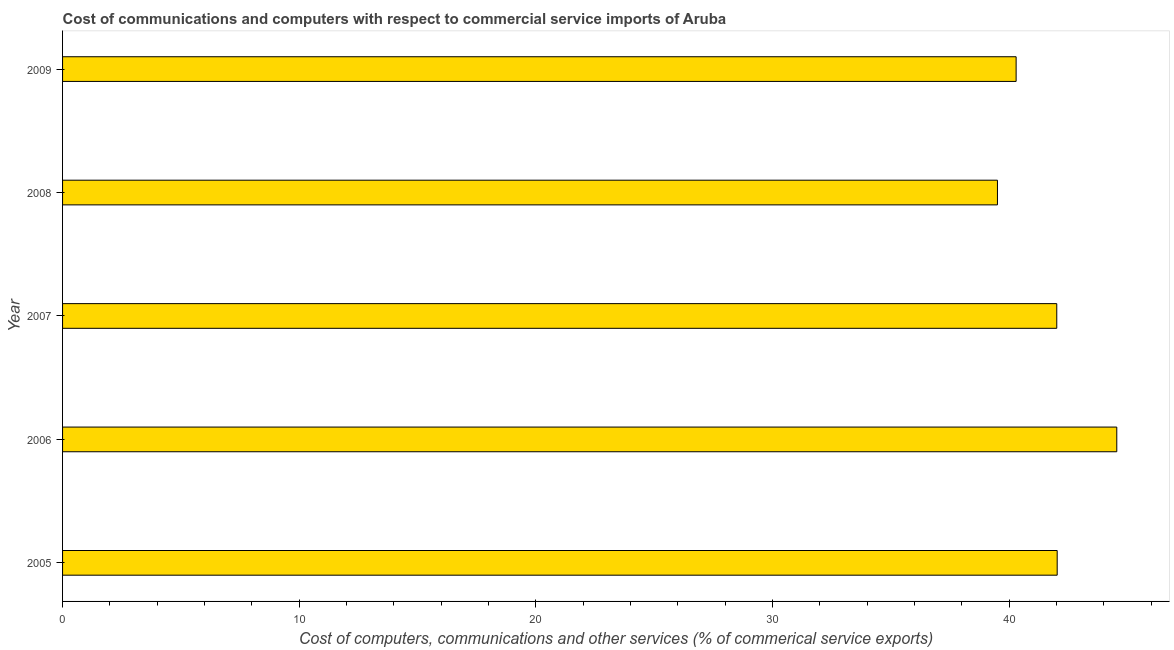What is the title of the graph?
Keep it short and to the point. Cost of communications and computers with respect to commercial service imports of Aruba. What is the label or title of the X-axis?
Provide a succinct answer. Cost of computers, communications and other services (% of commerical service exports). What is the cost of communications in 2008?
Make the answer very short. 39.51. Across all years, what is the maximum cost of communications?
Offer a very short reply. 44.55. Across all years, what is the minimum  computer and other services?
Offer a very short reply. 39.51. In which year was the cost of communications maximum?
Your response must be concise. 2006. What is the sum of the cost of communications?
Your response must be concise. 208.4. What is the difference between the  computer and other services in 2005 and 2006?
Your response must be concise. -2.52. What is the average  computer and other services per year?
Provide a succinct answer. 41.68. What is the median  computer and other services?
Provide a succinct answer. 42.01. Do a majority of the years between 2008 and 2005 (inclusive) have  computer and other services greater than 40 %?
Provide a short and direct response. Yes. What is the ratio of the  computer and other services in 2005 to that in 2009?
Make the answer very short. 1.04. What is the difference between the highest and the second highest  computer and other services?
Ensure brevity in your answer.  2.52. Is the sum of the  computer and other services in 2005 and 2008 greater than the maximum  computer and other services across all years?
Provide a short and direct response. Yes. What is the difference between the highest and the lowest cost of communications?
Your response must be concise. 5.04. How many bars are there?
Your answer should be very brief. 5. How many years are there in the graph?
Give a very brief answer. 5. What is the difference between two consecutive major ticks on the X-axis?
Ensure brevity in your answer.  10. Are the values on the major ticks of X-axis written in scientific E-notation?
Offer a terse response. No. What is the Cost of computers, communications and other services (% of commerical service exports) in 2005?
Provide a short and direct response. 42.03. What is the Cost of computers, communications and other services (% of commerical service exports) in 2006?
Provide a succinct answer. 44.55. What is the Cost of computers, communications and other services (% of commerical service exports) in 2007?
Provide a short and direct response. 42.01. What is the Cost of computers, communications and other services (% of commerical service exports) in 2008?
Your answer should be compact. 39.51. What is the Cost of computers, communications and other services (% of commerical service exports) in 2009?
Keep it short and to the point. 40.3. What is the difference between the Cost of computers, communications and other services (% of commerical service exports) in 2005 and 2006?
Make the answer very short. -2.52. What is the difference between the Cost of computers, communications and other services (% of commerical service exports) in 2005 and 2007?
Provide a short and direct response. 0.02. What is the difference between the Cost of computers, communications and other services (% of commerical service exports) in 2005 and 2008?
Offer a very short reply. 2.52. What is the difference between the Cost of computers, communications and other services (% of commerical service exports) in 2005 and 2009?
Give a very brief answer. 1.73. What is the difference between the Cost of computers, communications and other services (% of commerical service exports) in 2006 and 2007?
Your answer should be very brief. 2.54. What is the difference between the Cost of computers, communications and other services (% of commerical service exports) in 2006 and 2008?
Ensure brevity in your answer.  5.04. What is the difference between the Cost of computers, communications and other services (% of commerical service exports) in 2006 and 2009?
Your answer should be very brief. 4.25. What is the difference between the Cost of computers, communications and other services (% of commerical service exports) in 2007 and 2008?
Provide a succinct answer. 2.51. What is the difference between the Cost of computers, communications and other services (% of commerical service exports) in 2007 and 2009?
Your answer should be very brief. 1.72. What is the difference between the Cost of computers, communications and other services (% of commerical service exports) in 2008 and 2009?
Offer a terse response. -0.79. What is the ratio of the Cost of computers, communications and other services (% of commerical service exports) in 2005 to that in 2006?
Your response must be concise. 0.94. What is the ratio of the Cost of computers, communications and other services (% of commerical service exports) in 2005 to that in 2007?
Keep it short and to the point. 1. What is the ratio of the Cost of computers, communications and other services (% of commerical service exports) in 2005 to that in 2008?
Offer a very short reply. 1.06. What is the ratio of the Cost of computers, communications and other services (% of commerical service exports) in 2005 to that in 2009?
Your answer should be compact. 1.04. What is the ratio of the Cost of computers, communications and other services (% of commerical service exports) in 2006 to that in 2007?
Your answer should be very brief. 1.06. What is the ratio of the Cost of computers, communications and other services (% of commerical service exports) in 2006 to that in 2008?
Provide a succinct answer. 1.13. What is the ratio of the Cost of computers, communications and other services (% of commerical service exports) in 2006 to that in 2009?
Keep it short and to the point. 1.11. What is the ratio of the Cost of computers, communications and other services (% of commerical service exports) in 2007 to that in 2008?
Make the answer very short. 1.06. What is the ratio of the Cost of computers, communications and other services (% of commerical service exports) in 2007 to that in 2009?
Offer a very short reply. 1.04. 